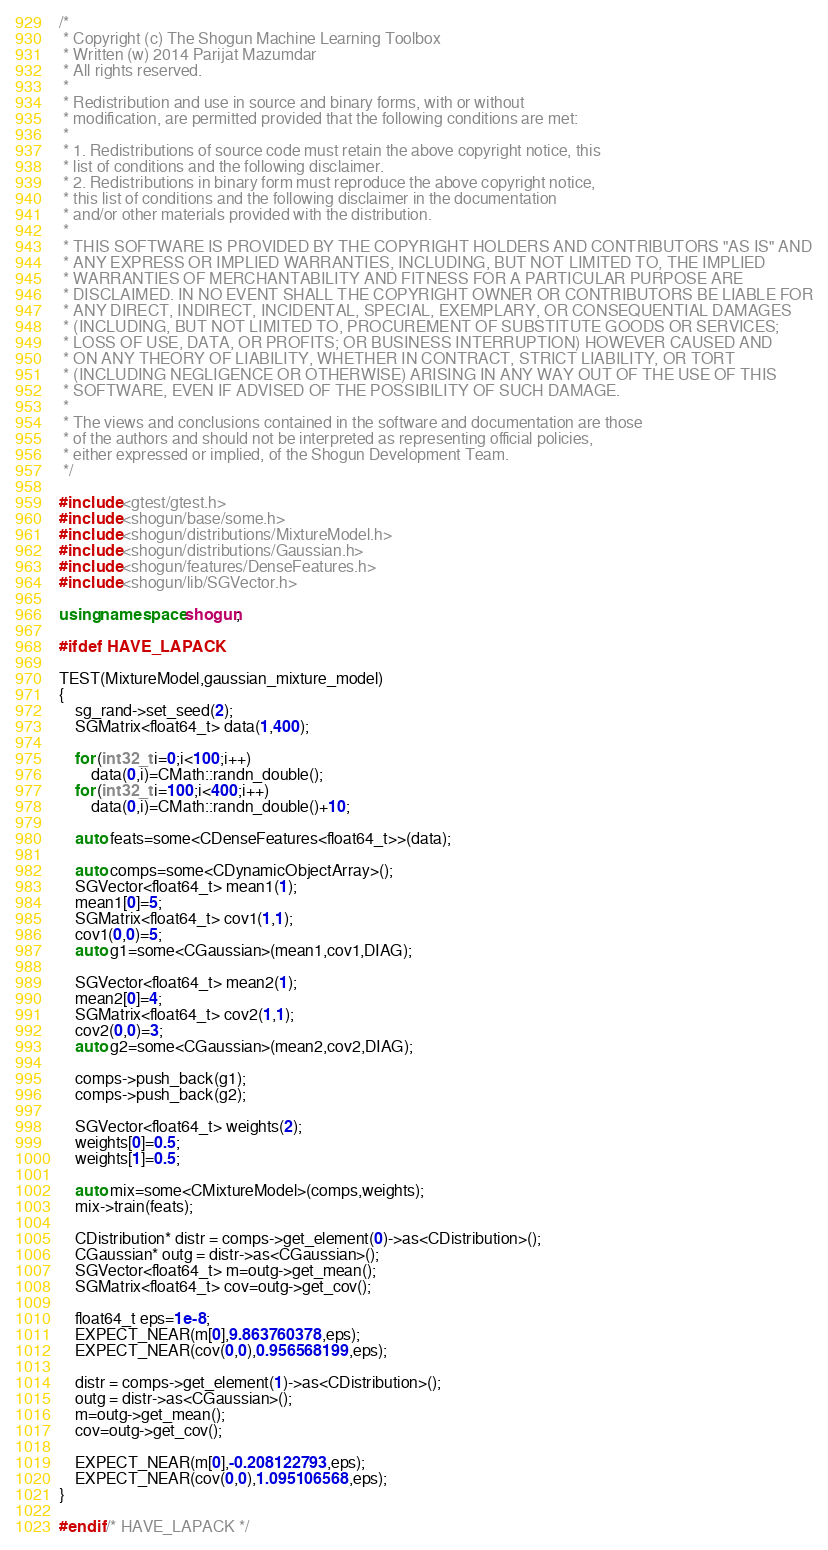Convert code to text. <code><loc_0><loc_0><loc_500><loc_500><_C++_>/*
 * Copyright (c) The Shogun Machine Learning Toolbox
 * Written (w) 2014 Parijat Mazumdar
 * All rights reserved.
 *
 * Redistribution and use in source and binary forms, with or without
 * modification, are permitted provided that the following conditions are met:
 *
 * 1. Redistributions of source code must retain the above copyright notice, this
 * list of conditions and the following disclaimer.
 * 2. Redistributions in binary form must reproduce the above copyright notice,
 * this list of conditions and the following disclaimer in the documentation
 * and/or other materials provided with the distribution.
 *
 * THIS SOFTWARE IS PROVIDED BY THE COPYRIGHT HOLDERS AND CONTRIBUTORS "AS IS" AND
 * ANY EXPRESS OR IMPLIED WARRANTIES, INCLUDING, BUT NOT LIMITED TO, THE IMPLIED
 * WARRANTIES OF MERCHANTABILITY AND FITNESS FOR A PARTICULAR PURPOSE ARE
 * DISCLAIMED. IN NO EVENT SHALL THE COPYRIGHT OWNER OR CONTRIBUTORS BE LIABLE FOR
 * ANY DIRECT, INDIRECT, INCIDENTAL, SPECIAL, EXEMPLARY, OR CONSEQUENTIAL DAMAGES
 * (INCLUDING, BUT NOT LIMITED TO, PROCUREMENT OF SUBSTITUTE GOODS OR SERVICES;
 * LOSS OF USE, DATA, OR PROFITS; OR BUSINESS INTERRUPTION) HOWEVER CAUSED AND
 * ON ANY THEORY OF LIABILITY, WHETHER IN CONTRACT, STRICT LIABILITY, OR TORT
 * (INCLUDING NEGLIGENCE OR OTHERWISE) ARISING IN ANY WAY OUT OF THE USE OF THIS
 * SOFTWARE, EVEN IF ADVISED OF THE POSSIBILITY OF SUCH DAMAGE.
 *
 * The views and conclusions contained in the software and documentation are those
 * of the authors and should not be interpreted as representing official policies,
 * either expressed or implied, of the Shogun Development Team.
 */

#include <gtest/gtest.h>
#include <shogun/base/some.h>
#include <shogun/distributions/MixtureModel.h>
#include <shogun/distributions/Gaussian.h>
#include <shogun/features/DenseFeatures.h>
#include <shogun/lib/SGVector.h>

using namespace shogun;

#ifdef HAVE_LAPACK

TEST(MixtureModel,gaussian_mixture_model)
{
	sg_rand->set_seed(2);
	SGMatrix<float64_t> data(1,400);

	for (int32_t i=0;i<100;i++)
		data(0,i)=CMath::randn_double();
	for (int32_t i=100;i<400;i++)
		data(0,i)=CMath::randn_double()+10;

	auto feats=some<CDenseFeatures<float64_t>>(data);

	auto comps=some<CDynamicObjectArray>();
	SGVector<float64_t> mean1(1);
	mean1[0]=5;
	SGMatrix<float64_t> cov1(1,1);
	cov1(0,0)=5;
	auto g1=some<CGaussian>(mean1,cov1,DIAG);

	SGVector<float64_t> mean2(1);
	mean2[0]=4;
	SGMatrix<float64_t> cov2(1,1);
	cov2(0,0)=3;
	auto g2=some<CGaussian>(mean2,cov2,DIAG);

	comps->push_back(g1);
	comps->push_back(g2);

	SGVector<float64_t> weights(2);
	weights[0]=0.5;
	weights[1]=0.5;

	auto mix=some<CMixtureModel>(comps,weights);
	mix->train(feats);

	CDistribution* distr = comps->get_element(0)->as<CDistribution>();
	CGaussian* outg = distr->as<CGaussian>();
	SGVector<float64_t> m=outg->get_mean();
	SGMatrix<float64_t> cov=outg->get_cov();

	float64_t eps=1e-8;
	EXPECT_NEAR(m[0],9.863760378,eps);
	EXPECT_NEAR(cov(0,0),0.956568199,eps);

	distr = comps->get_element(1)->as<CDistribution>();
	outg = distr->as<CGaussian>();
	m=outg->get_mean();
	cov=outg->get_cov();

	EXPECT_NEAR(m[0],-0.208122793,eps);
	EXPECT_NEAR(cov(0,0),1.095106568,eps);
}

#endif /* HAVE_LAPACK */
</code> 